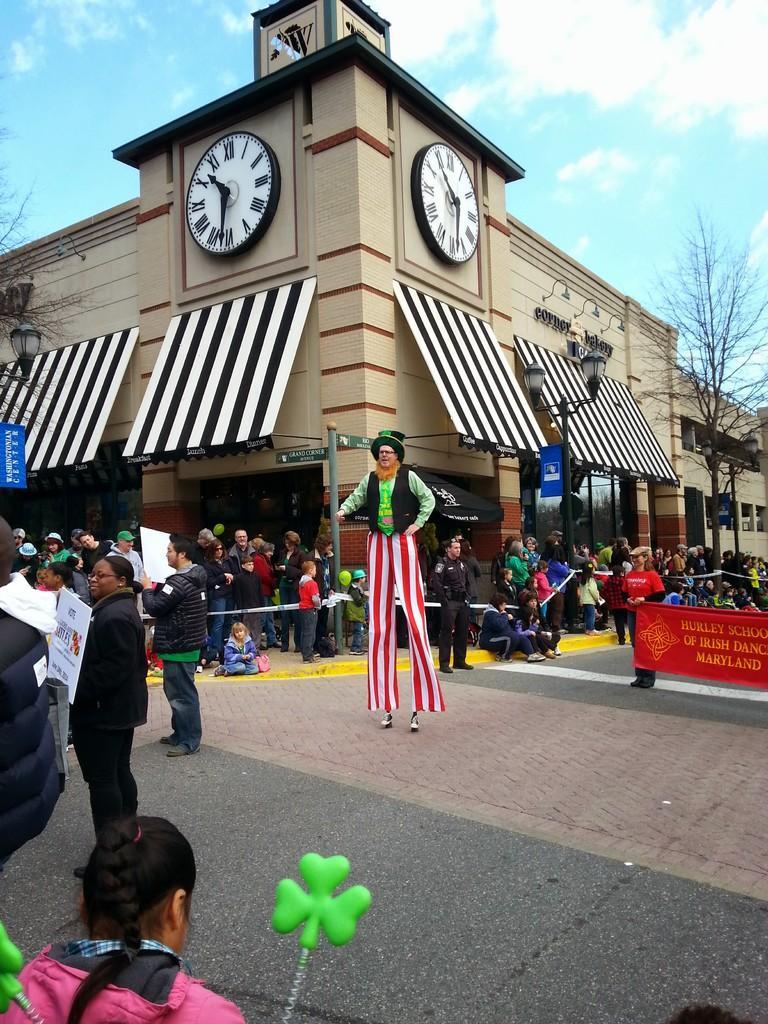Please provide a concise description of this image. In this image there are buildings and trees we can see people and there is a banner. There is a pole. In the background there is sky. 